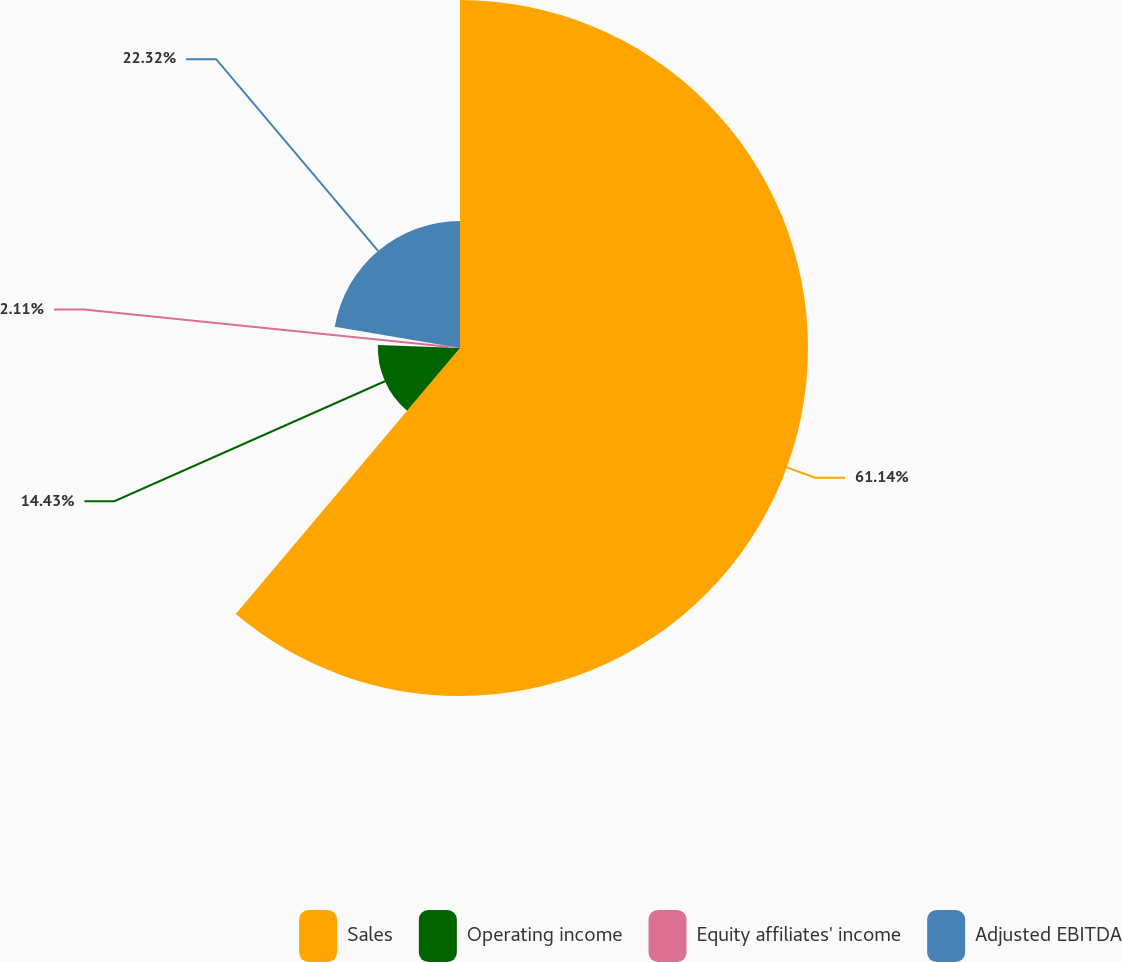Convert chart. <chart><loc_0><loc_0><loc_500><loc_500><pie_chart><fcel>Sales<fcel>Operating income<fcel>Equity affiliates' income<fcel>Adjusted EBITDA<nl><fcel>61.15%<fcel>14.43%<fcel>2.11%<fcel>22.32%<nl></chart> 